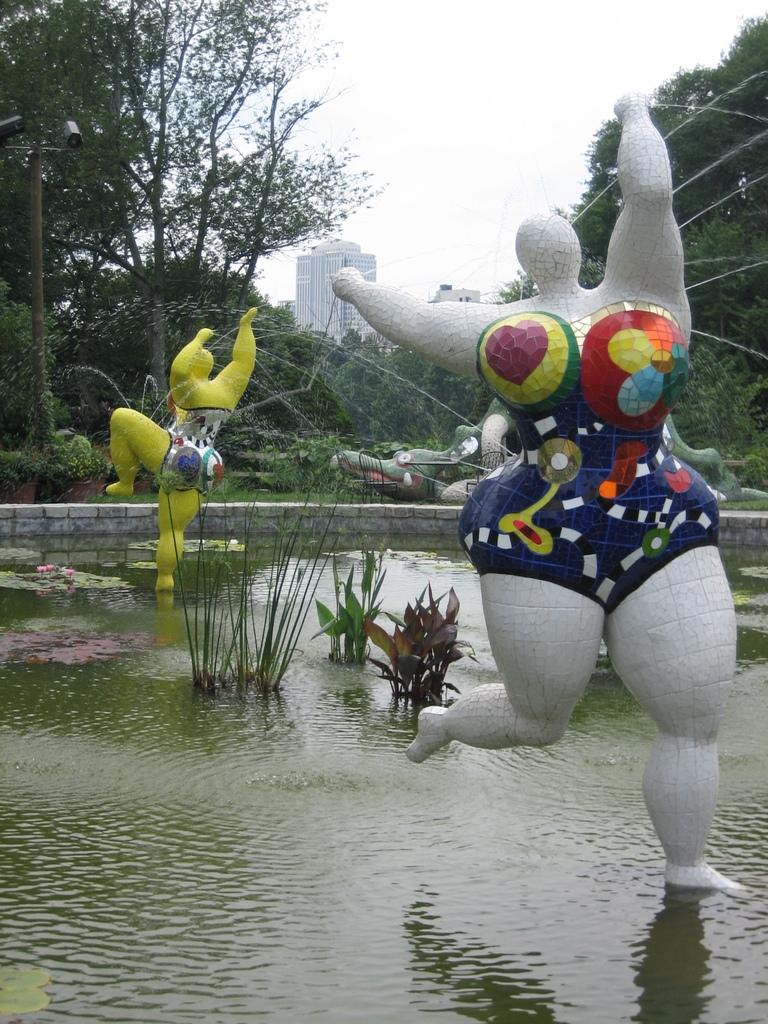What is located in the pond in the image? There are statues in the pond. What is visible in the image besides the statues? There is water visible in the image. What can be seen in the background of the image? There are buildings and trees in the background of the image. What type of coat is draped over the statue in the image? There is no coat present on the statues in the image. What impulse might have led to the creation of the statues in the image? The image does not provide information about the motivation behind the creation of the statues, so we cannot determine the impulse that led to their creation. 